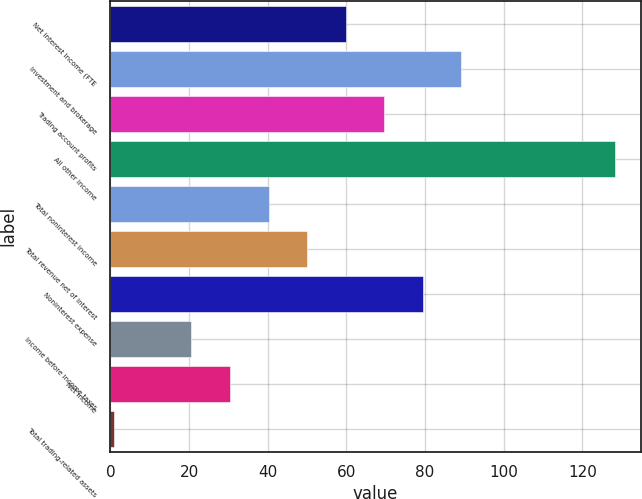Convert chart. <chart><loc_0><loc_0><loc_500><loc_500><bar_chart><fcel>Net interest income (FTE<fcel>Investment and brokerage<fcel>Trading account profits<fcel>All other income<fcel>Total noninterest income<fcel>Total revenue net of interest<fcel>Noninterest expense<fcel>Income before income taxes<fcel>Net income<fcel>Total trading-related assets<nl><fcel>59.8<fcel>89.2<fcel>69.6<fcel>128.4<fcel>40.2<fcel>50<fcel>79.4<fcel>20.6<fcel>30.4<fcel>1<nl></chart> 